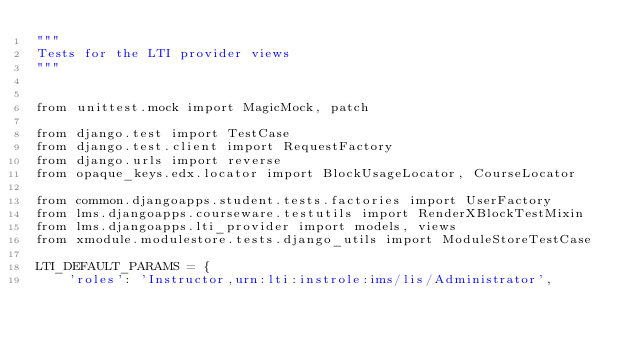Convert code to text. <code><loc_0><loc_0><loc_500><loc_500><_Python_>"""
Tests for the LTI provider views
"""


from unittest.mock import MagicMock, patch

from django.test import TestCase
from django.test.client import RequestFactory
from django.urls import reverse
from opaque_keys.edx.locator import BlockUsageLocator, CourseLocator

from common.djangoapps.student.tests.factories import UserFactory
from lms.djangoapps.courseware.testutils import RenderXBlockTestMixin
from lms.djangoapps.lti_provider import models, views
from xmodule.modulestore.tests.django_utils import ModuleStoreTestCase

LTI_DEFAULT_PARAMS = {
    'roles': 'Instructor,urn:lti:instrole:ims/lis/Administrator',</code> 